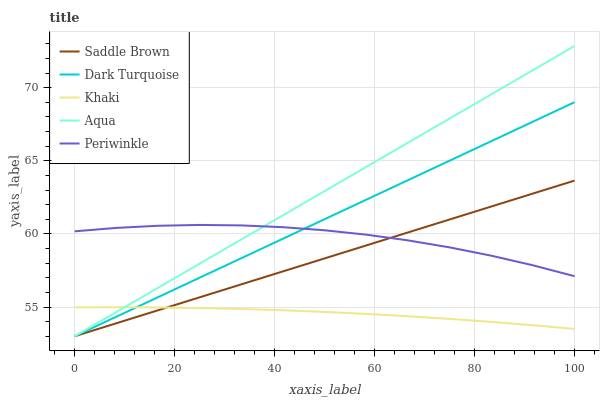Does Khaki have the minimum area under the curve?
Answer yes or no. Yes. Does Aqua have the maximum area under the curve?
Answer yes or no. Yes. Does Periwinkle have the minimum area under the curve?
Answer yes or no. No. Does Periwinkle have the maximum area under the curve?
Answer yes or no. No. Is Saddle Brown the smoothest?
Answer yes or no. Yes. Is Periwinkle the roughest?
Answer yes or no. Yes. Is Khaki the smoothest?
Answer yes or no. No. Is Khaki the roughest?
Answer yes or no. No. Does Dark Turquoise have the lowest value?
Answer yes or no. Yes. Does Khaki have the lowest value?
Answer yes or no. No. Does Aqua have the highest value?
Answer yes or no. Yes. Does Periwinkle have the highest value?
Answer yes or no. No. Is Khaki less than Periwinkle?
Answer yes or no. Yes. Is Periwinkle greater than Khaki?
Answer yes or no. Yes. Does Dark Turquoise intersect Aqua?
Answer yes or no. Yes. Is Dark Turquoise less than Aqua?
Answer yes or no. No. Is Dark Turquoise greater than Aqua?
Answer yes or no. No. Does Khaki intersect Periwinkle?
Answer yes or no. No. 